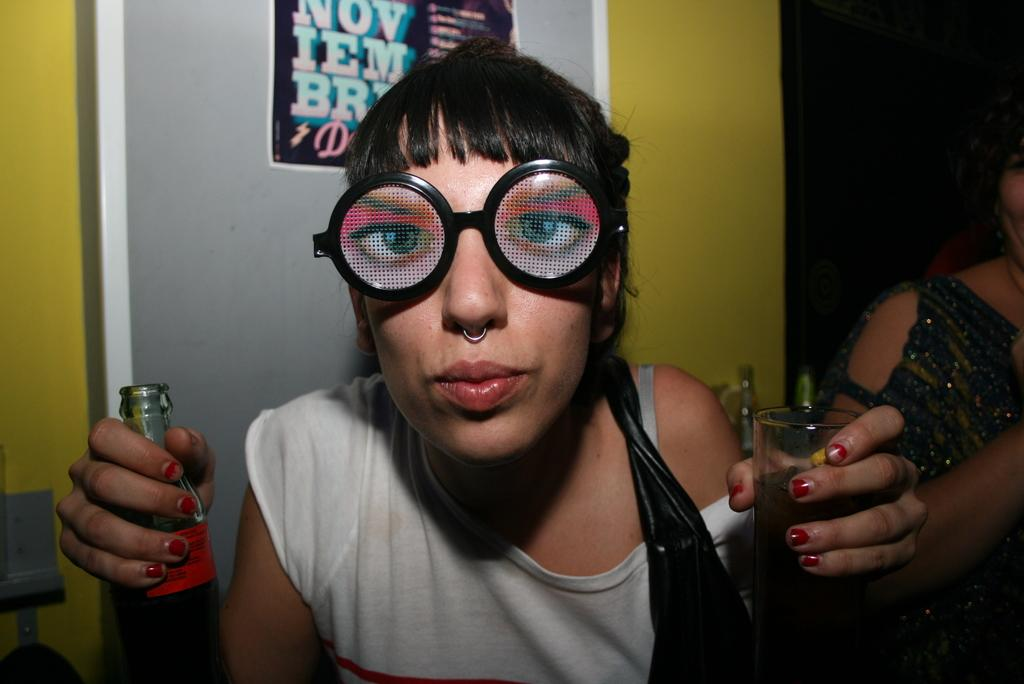What is the main subject of the image? There is a person in the image. What is the person holding in the image? The person is holding a bottle and a glass. What type of blood is visible on the person's hands in the image? There is no blood visible on the person's hands in the image. Is the person using a whip or a skate in the image? There is no whip or skate present in the image. 